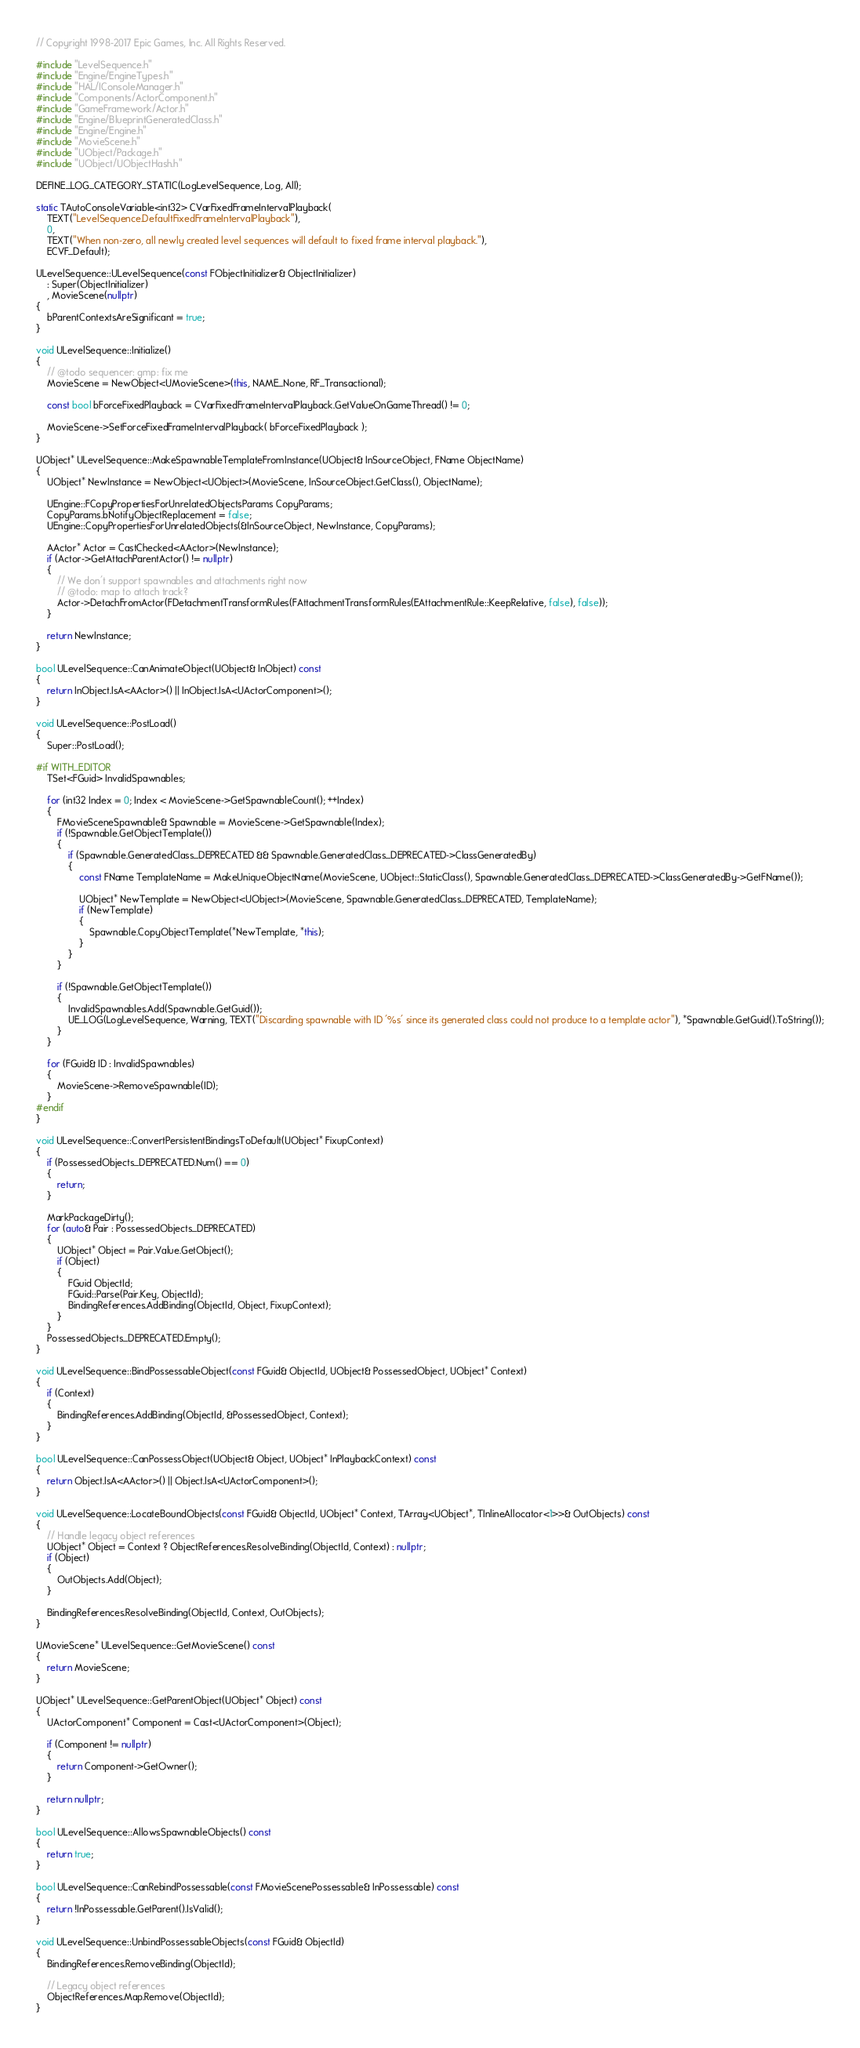<code> <loc_0><loc_0><loc_500><loc_500><_C++_>// Copyright 1998-2017 Epic Games, Inc. All Rights Reserved.

#include "LevelSequence.h"
#include "Engine/EngineTypes.h"
#include "HAL/IConsoleManager.h"
#include "Components/ActorComponent.h"
#include "GameFramework/Actor.h"
#include "Engine/BlueprintGeneratedClass.h"
#include "Engine/Engine.h"
#include "MovieScene.h"
#include "UObject/Package.h"
#include "UObject/UObjectHash.h"

DEFINE_LOG_CATEGORY_STATIC(LogLevelSequence, Log, All);

static TAutoConsoleVariable<int32> CVarFixedFrameIntervalPlayback(
	TEXT("LevelSequence.DefaultFixedFrameIntervalPlayback"),
	0,
	TEXT("When non-zero, all newly created level sequences will default to fixed frame interval playback."),
	ECVF_Default);

ULevelSequence::ULevelSequence(const FObjectInitializer& ObjectInitializer)
	: Super(ObjectInitializer)
	, MovieScene(nullptr)
{
	bParentContextsAreSignificant = true;
}

void ULevelSequence::Initialize()
{
	// @todo sequencer: gmp: fix me
	MovieScene = NewObject<UMovieScene>(this, NAME_None, RF_Transactional);

	const bool bForceFixedPlayback = CVarFixedFrameIntervalPlayback.GetValueOnGameThread() != 0;

	MovieScene->SetForceFixedFrameIntervalPlayback( bForceFixedPlayback );
}

UObject* ULevelSequence::MakeSpawnableTemplateFromInstance(UObject& InSourceObject, FName ObjectName)
{
	UObject* NewInstance = NewObject<UObject>(MovieScene, InSourceObject.GetClass(), ObjectName);

	UEngine::FCopyPropertiesForUnrelatedObjectsParams CopyParams;
	CopyParams.bNotifyObjectReplacement = false;
	UEngine::CopyPropertiesForUnrelatedObjects(&InSourceObject, NewInstance, CopyParams);

	AActor* Actor = CastChecked<AActor>(NewInstance);
	if (Actor->GetAttachParentActor() != nullptr)
	{
		// We don't support spawnables and attachments right now
		// @todo: map to attach track?
		Actor->DetachFromActor(FDetachmentTransformRules(FAttachmentTransformRules(EAttachmentRule::KeepRelative, false), false));
	}

	return NewInstance;
}

bool ULevelSequence::CanAnimateObject(UObject& InObject) const 
{
	return InObject.IsA<AActor>() || InObject.IsA<UActorComponent>();
}

void ULevelSequence::PostLoad()
{
	Super::PostLoad();

#if WITH_EDITOR
	TSet<FGuid> InvalidSpawnables;

	for (int32 Index = 0; Index < MovieScene->GetSpawnableCount(); ++Index)
	{
		FMovieSceneSpawnable& Spawnable = MovieScene->GetSpawnable(Index);
		if (!Spawnable.GetObjectTemplate())
		{
			if (Spawnable.GeneratedClass_DEPRECATED && Spawnable.GeneratedClass_DEPRECATED->ClassGeneratedBy)
			{
				const FName TemplateName = MakeUniqueObjectName(MovieScene, UObject::StaticClass(), Spawnable.GeneratedClass_DEPRECATED->ClassGeneratedBy->GetFName());

				UObject* NewTemplate = NewObject<UObject>(MovieScene, Spawnable.GeneratedClass_DEPRECATED, TemplateName);
				if (NewTemplate)
				{
					Spawnable.CopyObjectTemplate(*NewTemplate, *this);
				}
			}
		}

		if (!Spawnable.GetObjectTemplate())
		{
			InvalidSpawnables.Add(Spawnable.GetGuid());
			UE_LOG(LogLevelSequence, Warning, TEXT("Discarding spawnable with ID '%s' since its generated class could not produce to a template actor"), *Spawnable.GetGuid().ToString());
		}
	}

	for (FGuid& ID : InvalidSpawnables)
	{
		MovieScene->RemoveSpawnable(ID);
	}
#endif
}

void ULevelSequence::ConvertPersistentBindingsToDefault(UObject* FixupContext)
{
	if (PossessedObjects_DEPRECATED.Num() == 0)
	{
		return;
	}

	MarkPackageDirty();
	for (auto& Pair : PossessedObjects_DEPRECATED)
	{
		UObject* Object = Pair.Value.GetObject();
		if (Object)
		{
			FGuid ObjectId;
			FGuid::Parse(Pair.Key, ObjectId);
			BindingReferences.AddBinding(ObjectId, Object, FixupContext);
		}
	}
	PossessedObjects_DEPRECATED.Empty();
}

void ULevelSequence::BindPossessableObject(const FGuid& ObjectId, UObject& PossessedObject, UObject* Context)
{
	if (Context)
	{
		BindingReferences.AddBinding(ObjectId, &PossessedObject, Context);
	}
}

bool ULevelSequence::CanPossessObject(UObject& Object, UObject* InPlaybackContext) const
{
	return Object.IsA<AActor>() || Object.IsA<UActorComponent>();
}

void ULevelSequence::LocateBoundObjects(const FGuid& ObjectId, UObject* Context, TArray<UObject*, TInlineAllocator<1>>& OutObjects) const
{
	// Handle legacy object references
	UObject* Object = Context ? ObjectReferences.ResolveBinding(ObjectId, Context) : nullptr;
	if (Object)
	{
		OutObjects.Add(Object);
	}

	BindingReferences.ResolveBinding(ObjectId, Context, OutObjects);
}

UMovieScene* ULevelSequence::GetMovieScene() const
{
	return MovieScene;
}

UObject* ULevelSequence::GetParentObject(UObject* Object) const
{
	UActorComponent* Component = Cast<UActorComponent>(Object);

	if (Component != nullptr)
	{
		return Component->GetOwner();
	}

	return nullptr;
}

bool ULevelSequence::AllowsSpawnableObjects() const
{
	return true;
}

bool ULevelSequence::CanRebindPossessable(const FMovieScenePossessable& InPossessable) const
{
	return !InPossessable.GetParent().IsValid();
}

void ULevelSequence::UnbindPossessableObjects(const FGuid& ObjectId)
{
	BindingReferences.RemoveBinding(ObjectId);

	// Legacy object references
	ObjectReferences.Map.Remove(ObjectId);
}
</code> 